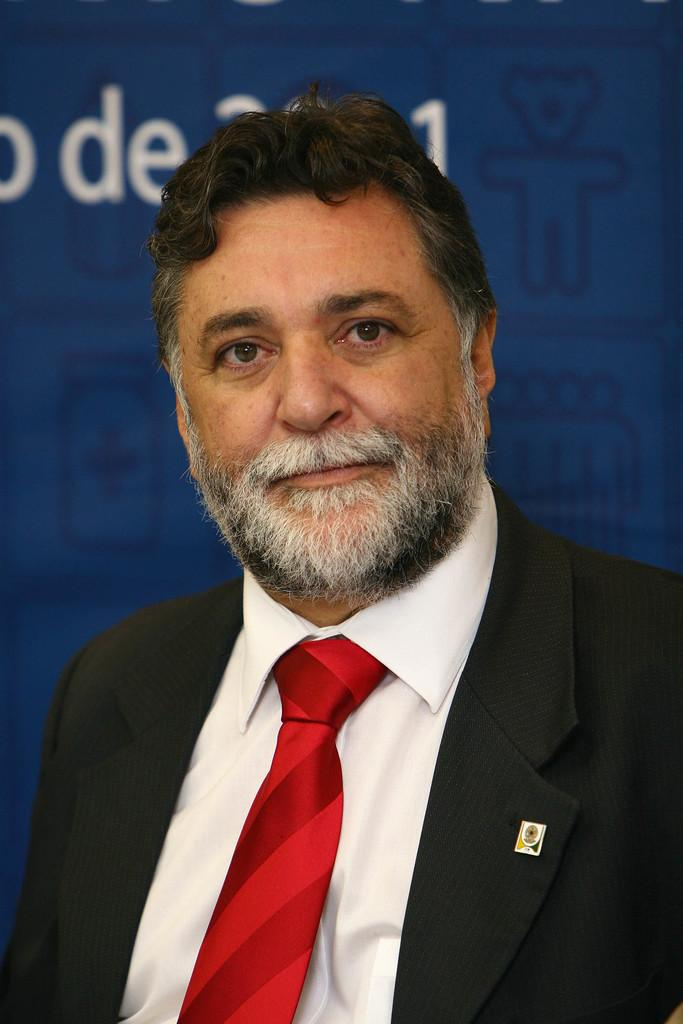Who is present in the image? There is a man in the image. What is the man doing in the image? The man is smiling in the image. What is the man wearing in the image? The man is wearing a black suit and a red tie in the image. What can be seen in the background of the image? The background of the image is blue. What book is the man holding in the image? There is no book present in the image. What type of pest can be seen crawling on the man's shoulder in the image? There is no pest present in the image. 